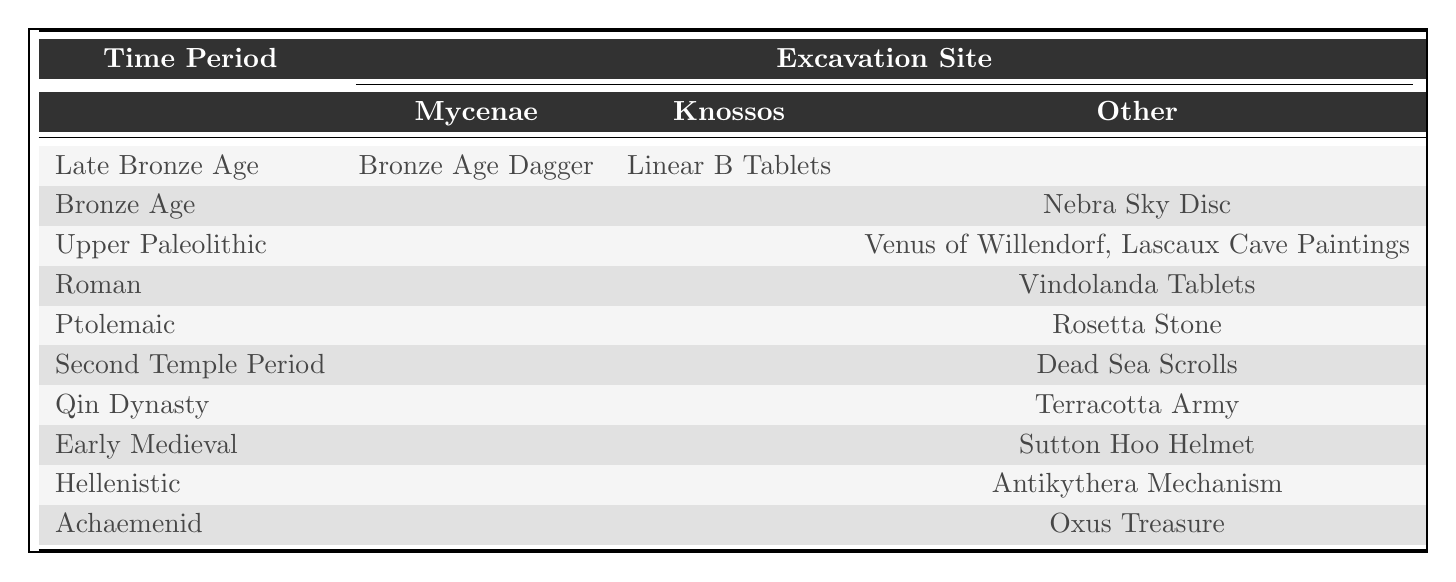What is the artifact discovered at Mycenae? The table shows the excavation site Mycenae under the Late Bronze Age, where the artifact is the Bronze Age Dagger.
Answer: Bronze Age Dagger How many artifacts are listed from the Upper Paleolithic time period? The Upper Paleolithic has two artifacts listed in the table: the Venus of Willendorf and Lascaux Cave Paintings. Therefore, the count is 2.
Answer: 2 Is the Terracotta Army well-preserved? The table states that the condition of the Terracotta Army is Excellent. Since Excellent implies a high degree of preservation, the answer is yes.
Answer: Yes What material is used for the Rosetta Stone? The table indicates that the Rosetta Stone is made of Granodiorite, which is specifically stated under the material column for that artifact.
Answer: Granodiorite Which time period has artifacts originating only from excavation sites other than Mycenae and Knossos? By examining the table, the Roman (Vindolanda Tablets), Ptolemaic (Rosetta Stone), Second Temple Period (Dead Sea Scrolls), Qin Dynasty (Terracotta Army), Early Medieval (Sutton Hoo Helmet), Hellenistic (Antikythera Mechanism), and Achaemenid (Oxus Treasure) periods all have artifacts listed under the “Other” site. Thus, these time periods have artifacts exclusively from other sites.
Answer: Roman, Ptolemaic, Second Temple Period, Qin Dynasty, Early Medieval, Hellenistic, Achaemenid What is the average age of the artifacts listed in the table? First, we calculate the age of each artifact by subtracting the year discovered from the current year (2023). The ages are: Bronze Age Dagger (147), Rosetta Stone (224), Dead Sea Scrolls (76), Terracotta Army (49), Venus of Willendorf (115), Sutton Hoo Helmet (84), Antikythera Mechanism (122), Lascaux Cave Paintings (83), Nebra Sky Disc (24), Vindolanda Tablets (50), Linear B Tablets (123), Oxus Treasure (146). Summing these ages gives us 147 + 224 + 76 + 49 + 115 + 84 + 122 + 83 + 24 + 50 + 123 + 146 = 1,198; there are 12 artifacts, so the average is 1198/12 ≈ 99.83.
Answer: 99.83 